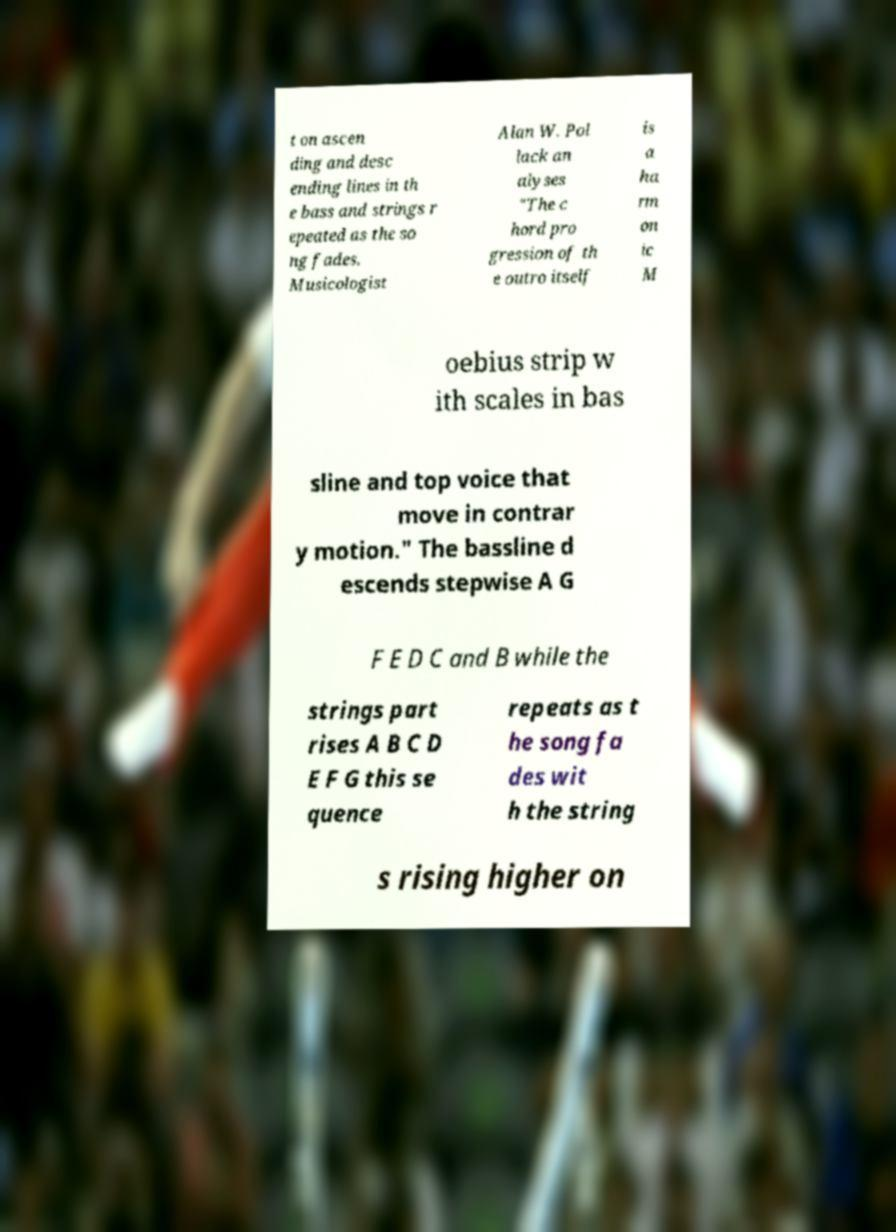For documentation purposes, I need the text within this image transcribed. Could you provide that? t on ascen ding and desc ending lines in th e bass and strings r epeated as the so ng fades. Musicologist Alan W. Pol lack an alyses "The c hord pro gression of th e outro itself is a ha rm on ic M oebius strip w ith scales in bas sline and top voice that move in contrar y motion." The bassline d escends stepwise A G F E D C and B while the strings part rises A B C D E F G this se quence repeats as t he song fa des wit h the string s rising higher on 